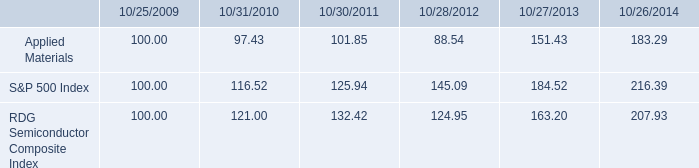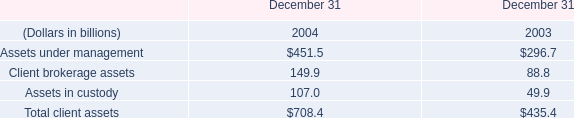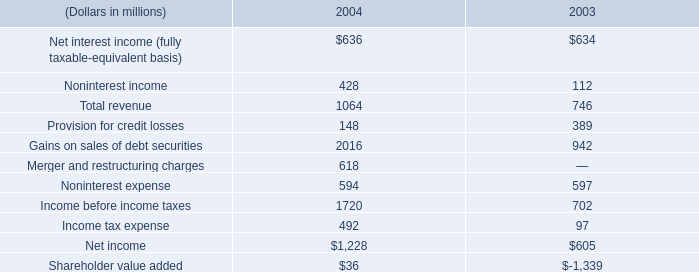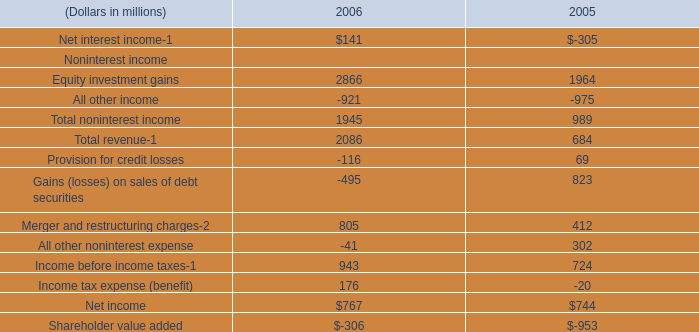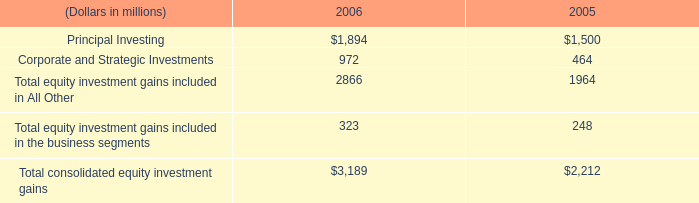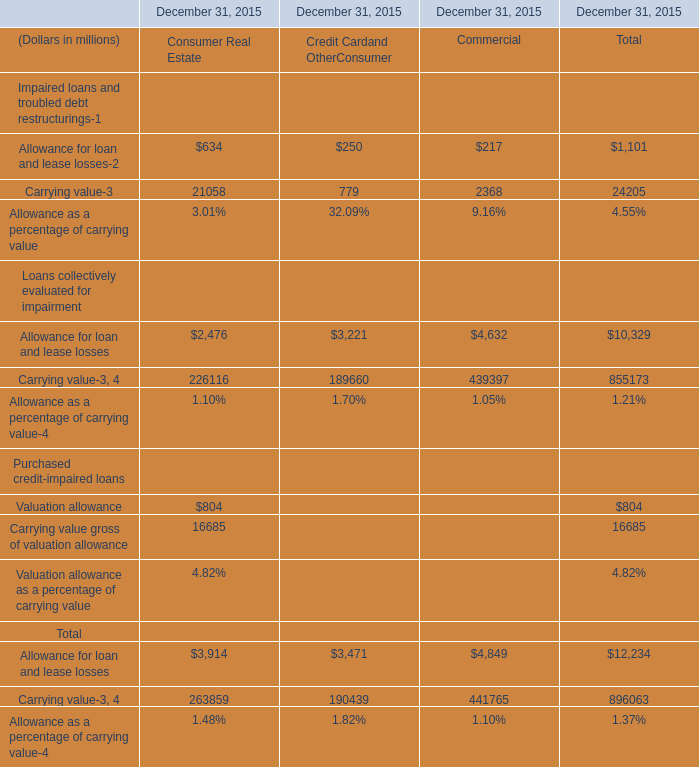how many shares received dividends during 2014 , ( in millions ) ? 
Computations: (487 / (0.10 * 4))
Answer: 1217.5. 